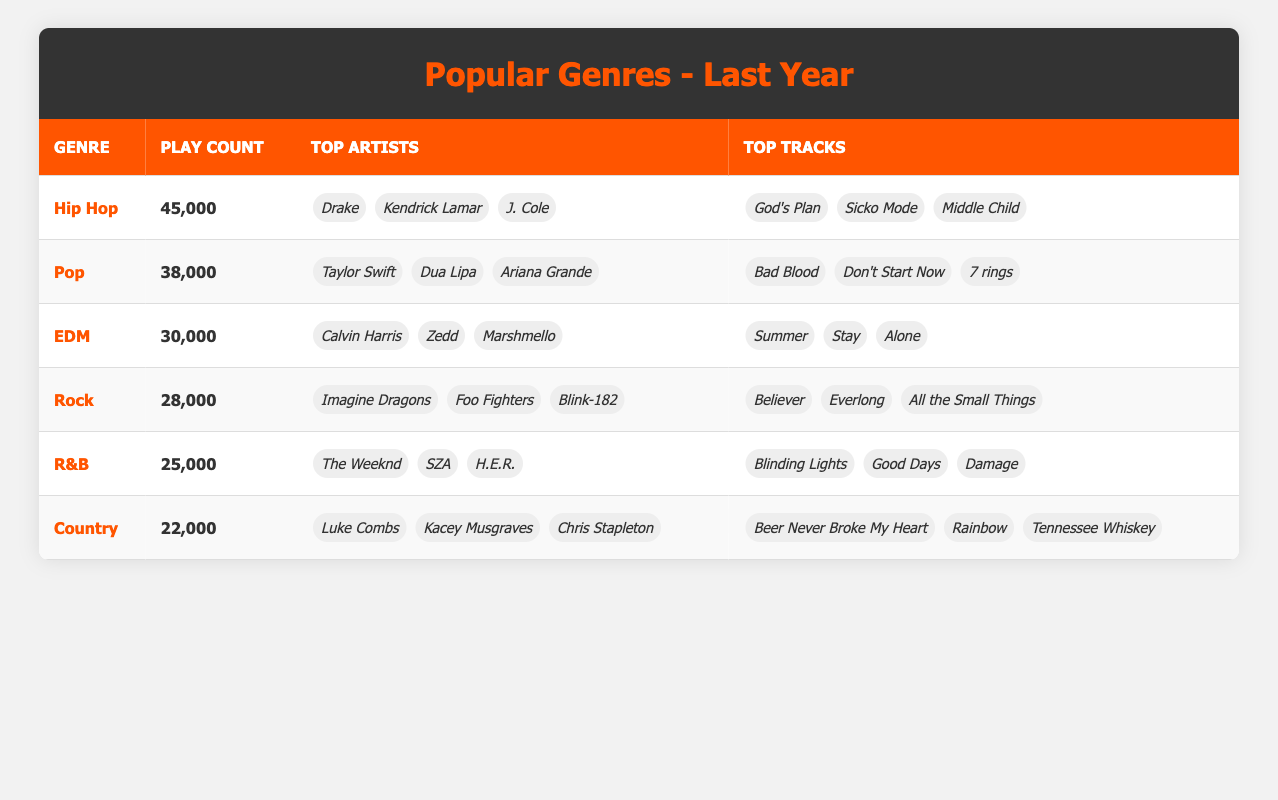What is the genre with the highest play count? By looking at the play counts for each genre, Hip Hop has the highest play count of 45,000.
Answer: Hip Hop How many top artists are listed for the Pop genre? The table shows that there are 3 top artists listed for the Pop genre: Taylor Swift, Dua Lipa, and Ariana Grande.
Answer: 3 What is the total play count for Rock and R&B genres combined? The play count for Rock is 28,000 and for R&B is 25,000. Adding these together: 28,000 + 25,000 = 53,000.
Answer: 53,000 Is “God's Plan” among the top tracks for any genre? Yes, according to the table, "God's Plan" is listed as one of the top tracks in the Hip Hop genre.
Answer: Yes Which genre has the least play count, and what is that count? By reviewing the play counts, the Country genre has the least count at 22,000.
Answer: Country, 22,000 What is the average play count of all the genres listed? The total play count for all genres is 45,000 + 38,000 + 30,000 + 28,000 + 25,000 + 22,000 = 188,000. There are 6 genres, so the average is 188,000 / 6 = 31,333.
Answer: 31,333 Which genre has top artists that include The Weeknd, SZA, and H.E.R.? The R&B genre has these artists listed as its top performers.
Answer: R&B Are there any genres that have a play count of over 30,000? Yes, there are three genres with play counts over 30,000: Hip Hop (45,000), Pop (38,000), and EDM (30,000).
Answer: Yes 